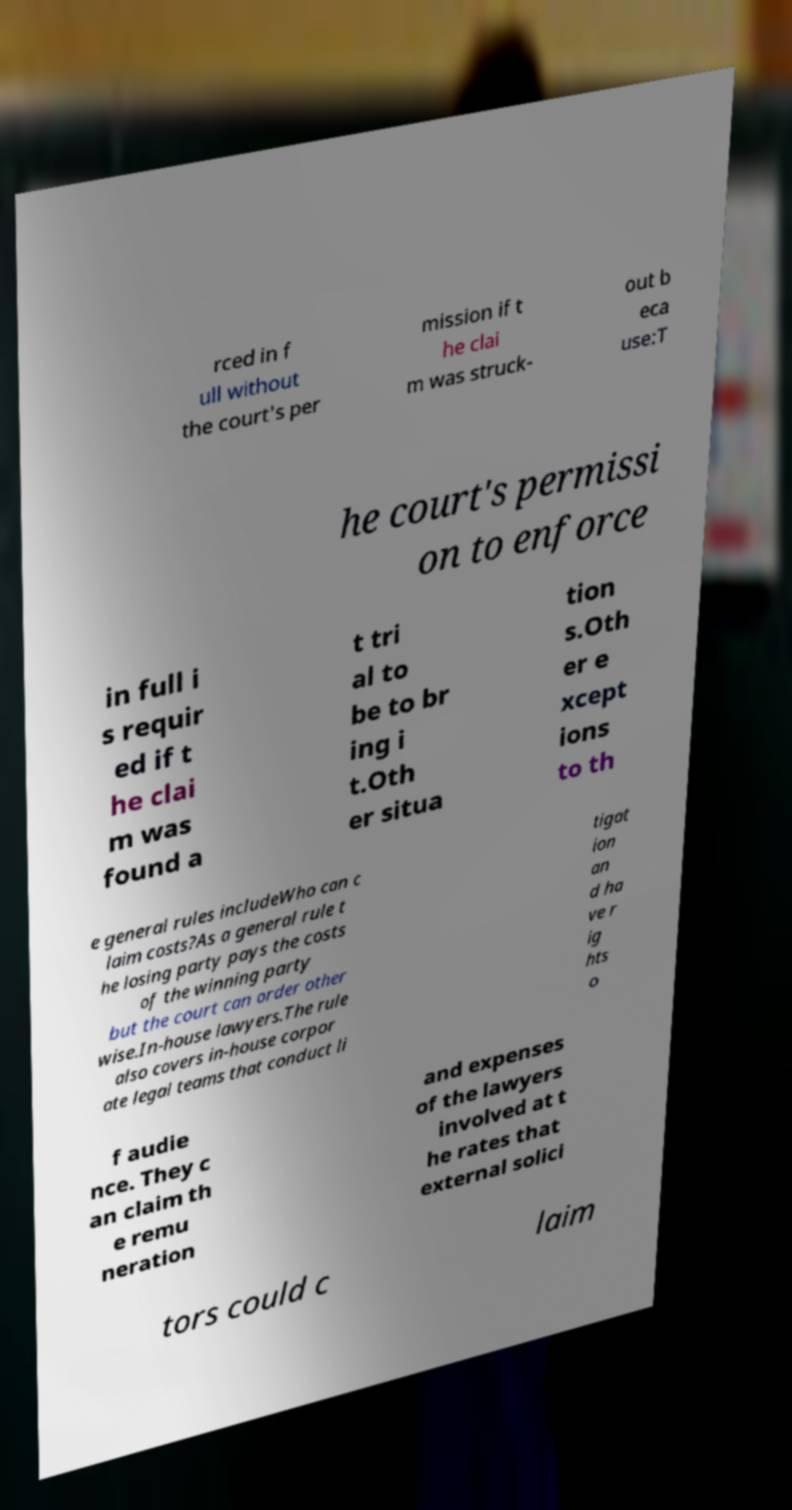For documentation purposes, I need the text within this image transcribed. Could you provide that? rced in f ull without the court's per mission if t he clai m was struck- out b eca use:T he court's permissi on to enforce in full i s requir ed if t he clai m was found a t tri al to be to br ing i t.Oth er situa tion s.Oth er e xcept ions to th e general rules includeWho can c laim costs?As a general rule t he losing party pays the costs of the winning party but the court can order other wise.In-house lawyers.The rule also covers in-house corpor ate legal teams that conduct li tigat ion an d ha ve r ig hts o f audie nce. They c an claim th e remu neration and expenses of the lawyers involved at t he rates that external solici tors could c laim 